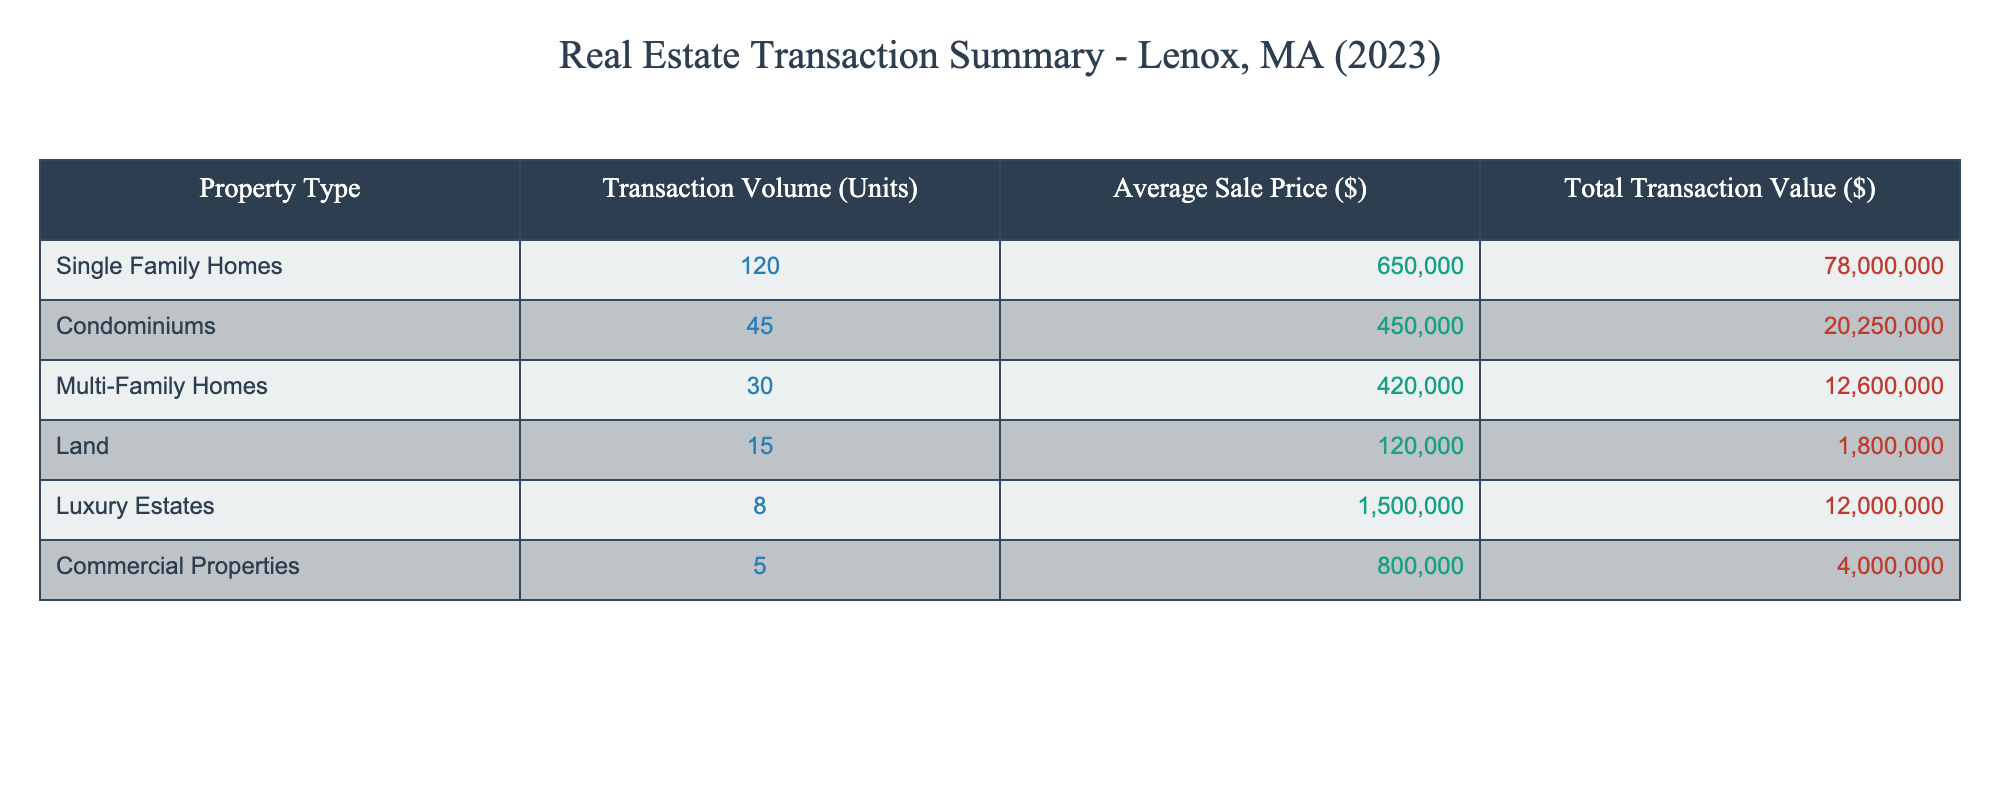What is the transaction volume for Single Family Homes? The transaction volume is listed directly in the table under 'Transaction Volume (Units)' for Single Family Homes, which shows 120 units.
Answer: 120 What is the average sale price of Multi-Family Homes? The average sale price is directly indicated in the table in the column for 'Average Sale Price ($)', which for Multi-Family Homes is $420,000.
Answer: $420,000 How many more units of Single Family Homes were sold compared to Commercial Properties? The transaction volumes for Single Family Homes and Commercial Properties are 120 and 5 units, respectively. To find the difference, subtract 5 from 120: 120 - 5 = 115.
Answer: 115 What is the total transaction value of Condominiums? The total transaction value for Condominiums is stated in the table under 'Total Transaction Value ($)', which is $20,250,000.
Answer: $20,250,000 Was the average sale price of Luxury Estates greater than the average sale price of Single Family Homes? The average sale price for Luxury Estates is $1,500,000 and for Single Family Homes it is $650,000. Since $1,500,000 is greater than $650,000, the statement is true.
Answer: Yes What is the average transaction volume percentage for Land and Luxury Estates combined compared to the total transaction volume? The total transaction volume is the sum of all units: 120 + 45 + 30 + 15 + 8 + 5 = 223. The combined transaction volume for Land (15) and Luxury Estates (8) is 15 + 8 = 23. The percentage is (23/223) * 100 ≈ 10.33%.
Answer: Approximately 10.33% What is the difference in total transaction value between Multi-Family Homes and Commercial Properties? The total transaction value for Multi-Family Homes is $12,600,000, and for Commercial Properties it is $4,000,000. To find the difference, subtract: $12,600,000 - $4,000,000 = $8,600,000.
Answer: $8,600,000 What type of property had the least number of transactions? The property type with the least number of transactions is listed in the table as Commercial Properties with just 5 units sold.
Answer: Commercial Properties If we were to rank property types by average sale price, which property type ranks second? To rank by average sale price: 1st is Luxury Estates ($1,500,000), 2nd is Single Family Homes ($650,000), then Condominiums ($450,000), Multi-Family Homes ($420,000), Land ($120,000), and finally Commercial Properties ($800,000). Therefore, the second rank is Single Family Homes.
Answer: Single Family Homes 